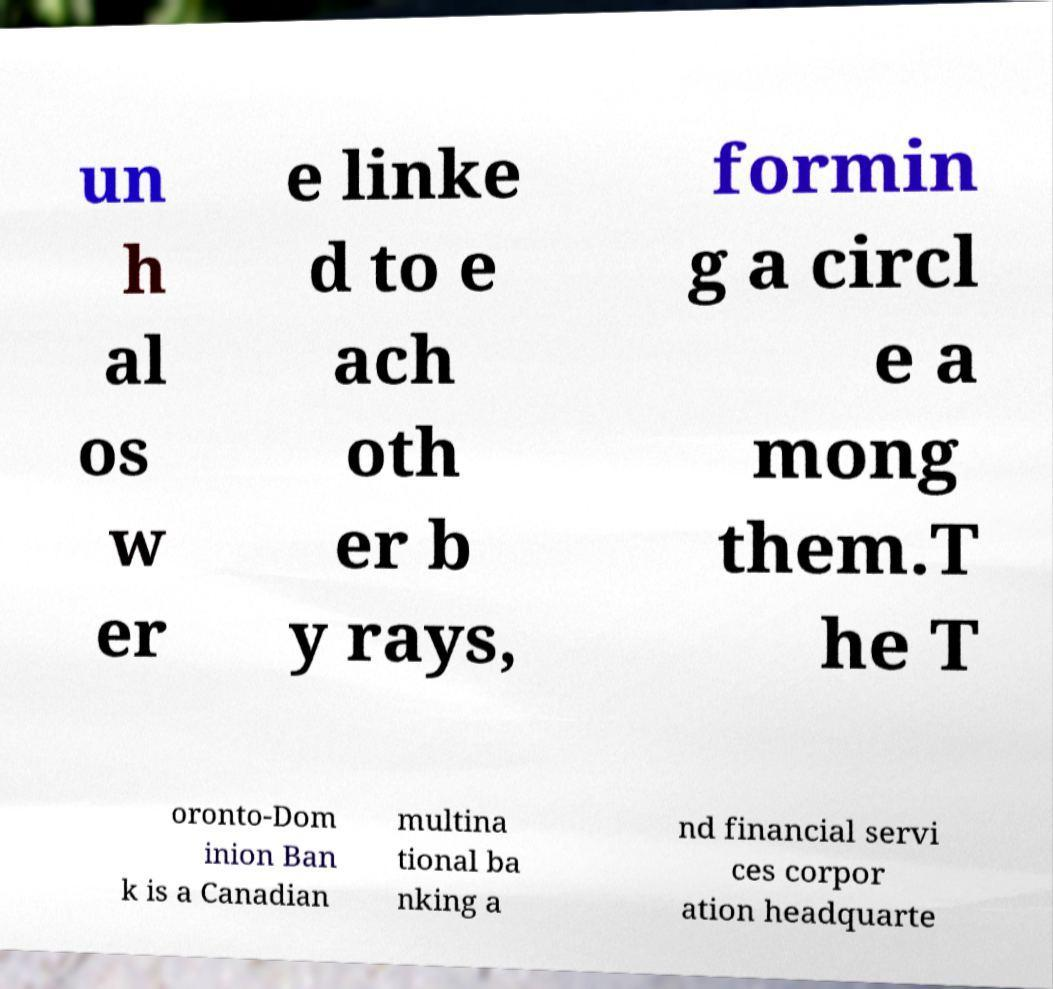For documentation purposes, I need the text within this image transcribed. Could you provide that? un h al os w er e linke d to e ach oth er b y rays, formin g a circl e a mong them.T he T oronto-Dom inion Ban k is a Canadian multina tional ba nking a nd financial servi ces corpor ation headquarte 